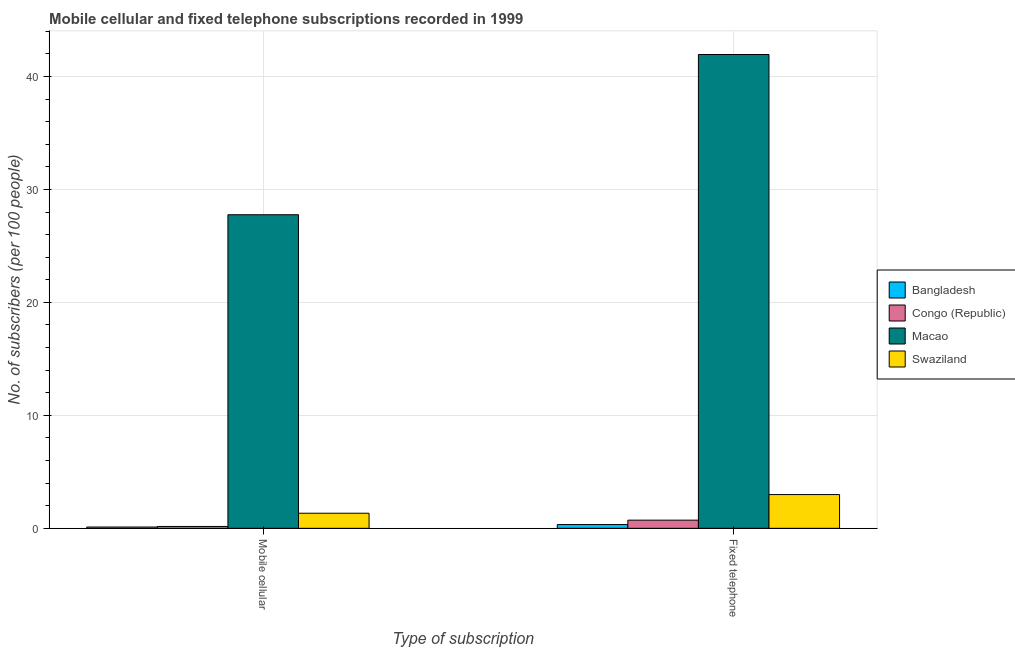How many different coloured bars are there?
Offer a very short reply. 4. Are the number of bars on each tick of the X-axis equal?
Offer a very short reply. Yes. How many bars are there on the 1st tick from the left?
Make the answer very short. 4. How many bars are there on the 1st tick from the right?
Offer a terse response. 4. What is the label of the 2nd group of bars from the left?
Your answer should be compact. Fixed telephone. What is the number of mobile cellular subscribers in Macao?
Give a very brief answer. 27.76. Across all countries, what is the maximum number of mobile cellular subscribers?
Offer a very short reply. 27.76. Across all countries, what is the minimum number of fixed telephone subscribers?
Provide a succinct answer. 0.33. In which country was the number of fixed telephone subscribers maximum?
Offer a terse response. Macao. In which country was the number of mobile cellular subscribers minimum?
Provide a succinct answer. Bangladesh. What is the total number of fixed telephone subscribers in the graph?
Your answer should be very brief. 45.99. What is the difference between the number of mobile cellular subscribers in Macao and that in Bangladesh?
Provide a short and direct response. 27.64. What is the difference between the number of fixed telephone subscribers in Bangladesh and the number of mobile cellular subscribers in Swaziland?
Offer a terse response. -1. What is the average number of fixed telephone subscribers per country?
Give a very brief answer. 11.5. What is the difference between the number of mobile cellular subscribers and number of fixed telephone subscribers in Congo (Republic)?
Provide a succinct answer. -0.56. In how many countries, is the number of fixed telephone subscribers greater than 36 ?
Make the answer very short. 1. What is the ratio of the number of fixed telephone subscribers in Bangladesh to that in Swaziland?
Your answer should be compact. 0.11. Is the number of mobile cellular subscribers in Swaziland less than that in Bangladesh?
Make the answer very short. No. In how many countries, is the number of mobile cellular subscribers greater than the average number of mobile cellular subscribers taken over all countries?
Keep it short and to the point. 1. What does the 2nd bar from the left in Fixed telephone represents?
Provide a short and direct response. Congo (Republic). What does the 4th bar from the right in Fixed telephone represents?
Provide a succinct answer. Bangladesh. Are all the bars in the graph horizontal?
Make the answer very short. No. How many countries are there in the graph?
Your answer should be compact. 4. What is the difference between two consecutive major ticks on the Y-axis?
Offer a terse response. 10. Are the values on the major ticks of Y-axis written in scientific E-notation?
Your answer should be very brief. No. Where does the legend appear in the graph?
Your answer should be very brief. Center right. How many legend labels are there?
Offer a very short reply. 4. How are the legend labels stacked?
Your answer should be very brief. Vertical. What is the title of the graph?
Provide a succinct answer. Mobile cellular and fixed telephone subscriptions recorded in 1999. What is the label or title of the X-axis?
Make the answer very short. Type of subscription. What is the label or title of the Y-axis?
Your answer should be very brief. No. of subscribers (per 100 people). What is the No. of subscribers (per 100 people) of Bangladesh in Mobile cellular?
Your response must be concise. 0.11. What is the No. of subscribers (per 100 people) of Congo (Republic) in Mobile cellular?
Keep it short and to the point. 0.16. What is the No. of subscribers (per 100 people) of Macao in Mobile cellular?
Your answer should be compact. 27.76. What is the No. of subscribers (per 100 people) in Swaziland in Mobile cellular?
Ensure brevity in your answer.  1.34. What is the No. of subscribers (per 100 people) of Bangladesh in Fixed telephone?
Give a very brief answer. 0.33. What is the No. of subscribers (per 100 people) of Congo (Republic) in Fixed telephone?
Offer a very short reply. 0.72. What is the No. of subscribers (per 100 people) of Macao in Fixed telephone?
Provide a short and direct response. 41.94. What is the No. of subscribers (per 100 people) in Swaziland in Fixed telephone?
Provide a short and direct response. 2.99. Across all Type of subscription, what is the maximum No. of subscribers (per 100 people) in Bangladesh?
Your answer should be compact. 0.33. Across all Type of subscription, what is the maximum No. of subscribers (per 100 people) in Congo (Republic)?
Provide a succinct answer. 0.72. Across all Type of subscription, what is the maximum No. of subscribers (per 100 people) in Macao?
Make the answer very short. 41.94. Across all Type of subscription, what is the maximum No. of subscribers (per 100 people) of Swaziland?
Provide a succinct answer. 2.99. Across all Type of subscription, what is the minimum No. of subscribers (per 100 people) of Bangladesh?
Ensure brevity in your answer.  0.11. Across all Type of subscription, what is the minimum No. of subscribers (per 100 people) in Congo (Republic)?
Offer a very short reply. 0.16. Across all Type of subscription, what is the minimum No. of subscribers (per 100 people) of Macao?
Your answer should be very brief. 27.76. Across all Type of subscription, what is the minimum No. of subscribers (per 100 people) of Swaziland?
Provide a succinct answer. 1.34. What is the total No. of subscribers (per 100 people) in Bangladesh in the graph?
Provide a short and direct response. 0.45. What is the total No. of subscribers (per 100 people) in Congo (Republic) in the graph?
Offer a terse response. 0.89. What is the total No. of subscribers (per 100 people) of Macao in the graph?
Make the answer very short. 69.7. What is the total No. of subscribers (per 100 people) of Swaziland in the graph?
Offer a terse response. 4.32. What is the difference between the No. of subscribers (per 100 people) in Bangladesh in Mobile cellular and that in Fixed telephone?
Your answer should be compact. -0.22. What is the difference between the No. of subscribers (per 100 people) in Congo (Republic) in Mobile cellular and that in Fixed telephone?
Your answer should be very brief. -0.56. What is the difference between the No. of subscribers (per 100 people) in Macao in Mobile cellular and that in Fixed telephone?
Your answer should be compact. -14.18. What is the difference between the No. of subscribers (per 100 people) in Swaziland in Mobile cellular and that in Fixed telephone?
Offer a terse response. -1.65. What is the difference between the No. of subscribers (per 100 people) of Bangladesh in Mobile cellular and the No. of subscribers (per 100 people) of Congo (Republic) in Fixed telephone?
Offer a very short reply. -0.61. What is the difference between the No. of subscribers (per 100 people) of Bangladesh in Mobile cellular and the No. of subscribers (per 100 people) of Macao in Fixed telephone?
Your answer should be very brief. -41.83. What is the difference between the No. of subscribers (per 100 people) of Bangladesh in Mobile cellular and the No. of subscribers (per 100 people) of Swaziland in Fixed telephone?
Your answer should be very brief. -2.87. What is the difference between the No. of subscribers (per 100 people) in Congo (Republic) in Mobile cellular and the No. of subscribers (per 100 people) in Macao in Fixed telephone?
Provide a succinct answer. -41.78. What is the difference between the No. of subscribers (per 100 people) in Congo (Republic) in Mobile cellular and the No. of subscribers (per 100 people) in Swaziland in Fixed telephone?
Ensure brevity in your answer.  -2.82. What is the difference between the No. of subscribers (per 100 people) of Macao in Mobile cellular and the No. of subscribers (per 100 people) of Swaziland in Fixed telephone?
Your answer should be compact. 24.77. What is the average No. of subscribers (per 100 people) of Bangladesh per Type of subscription?
Keep it short and to the point. 0.22. What is the average No. of subscribers (per 100 people) in Congo (Republic) per Type of subscription?
Give a very brief answer. 0.44. What is the average No. of subscribers (per 100 people) of Macao per Type of subscription?
Your answer should be very brief. 34.85. What is the average No. of subscribers (per 100 people) in Swaziland per Type of subscription?
Ensure brevity in your answer.  2.16. What is the difference between the No. of subscribers (per 100 people) in Bangladesh and No. of subscribers (per 100 people) in Congo (Republic) in Mobile cellular?
Offer a terse response. -0.05. What is the difference between the No. of subscribers (per 100 people) in Bangladesh and No. of subscribers (per 100 people) in Macao in Mobile cellular?
Keep it short and to the point. -27.64. What is the difference between the No. of subscribers (per 100 people) of Bangladesh and No. of subscribers (per 100 people) of Swaziland in Mobile cellular?
Offer a terse response. -1.22. What is the difference between the No. of subscribers (per 100 people) in Congo (Republic) and No. of subscribers (per 100 people) in Macao in Mobile cellular?
Your answer should be compact. -27.59. What is the difference between the No. of subscribers (per 100 people) in Congo (Republic) and No. of subscribers (per 100 people) in Swaziland in Mobile cellular?
Give a very brief answer. -1.17. What is the difference between the No. of subscribers (per 100 people) in Macao and No. of subscribers (per 100 people) in Swaziland in Mobile cellular?
Your answer should be very brief. 26.42. What is the difference between the No. of subscribers (per 100 people) of Bangladesh and No. of subscribers (per 100 people) of Congo (Republic) in Fixed telephone?
Ensure brevity in your answer.  -0.39. What is the difference between the No. of subscribers (per 100 people) in Bangladesh and No. of subscribers (per 100 people) in Macao in Fixed telephone?
Ensure brevity in your answer.  -41.61. What is the difference between the No. of subscribers (per 100 people) of Bangladesh and No. of subscribers (per 100 people) of Swaziland in Fixed telephone?
Provide a short and direct response. -2.65. What is the difference between the No. of subscribers (per 100 people) in Congo (Republic) and No. of subscribers (per 100 people) in Macao in Fixed telephone?
Your answer should be compact. -41.22. What is the difference between the No. of subscribers (per 100 people) in Congo (Republic) and No. of subscribers (per 100 people) in Swaziland in Fixed telephone?
Ensure brevity in your answer.  -2.26. What is the difference between the No. of subscribers (per 100 people) in Macao and No. of subscribers (per 100 people) in Swaziland in Fixed telephone?
Your response must be concise. 38.96. What is the ratio of the No. of subscribers (per 100 people) of Bangladesh in Mobile cellular to that in Fixed telephone?
Make the answer very short. 0.34. What is the ratio of the No. of subscribers (per 100 people) of Congo (Republic) in Mobile cellular to that in Fixed telephone?
Give a very brief answer. 0.23. What is the ratio of the No. of subscribers (per 100 people) of Macao in Mobile cellular to that in Fixed telephone?
Your response must be concise. 0.66. What is the ratio of the No. of subscribers (per 100 people) in Swaziland in Mobile cellular to that in Fixed telephone?
Ensure brevity in your answer.  0.45. What is the difference between the highest and the second highest No. of subscribers (per 100 people) of Bangladesh?
Offer a terse response. 0.22. What is the difference between the highest and the second highest No. of subscribers (per 100 people) of Congo (Republic)?
Keep it short and to the point. 0.56. What is the difference between the highest and the second highest No. of subscribers (per 100 people) of Macao?
Your answer should be very brief. 14.18. What is the difference between the highest and the second highest No. of subscribers (per 100 people) in Swaziland?
Provide a short and direct response. 1.65. What is the difference between the highest and the lowest No. of subscribers (per 100 people) of Bangladesh?
Give a very brief answer. 0.22. What is the difference between the highest and the lowest No. of subscribers (per 100 people) in Congo (Republic)?
Ensure brevity in your answer.  0.56. What is the difference between the highest and the lowest No. of subscribers (per 100 people) of Macao?
Provide a succinct answer. 14.18. What is the difference between the highest and the lowest No. of subscribers (per 100 people) in Swaziland?
Offer a terse response. 1.65. 